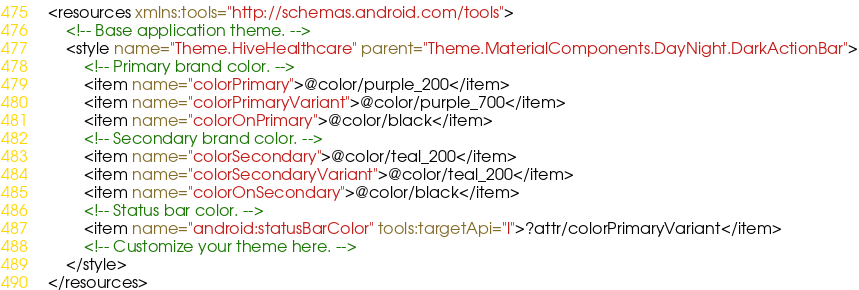<code> <loc_0><loc_0><loc_500><loc_500><_XML_><resources xmlns:tools="http://schemas.android.com/tools">
    <!-- Base application theme. -->
    <style name="Theme.HiveHealthcare" parent="Theme.MaterialComponents.DayNight.DarkActionBar">
        <!-- Primary brand color. -->
        <item name="colorPrimary">@color/purple_200</item>
        <item name="colorPrimaryVariant">@color/purple_700</item>
        <item name="colorOnPrimary">@color/black</item>
        <!-- Secondary brand color. -->
        <item name="colorSecondary">@color/teal_200</item>
        <item name="colorSecondaryVariant">@color/teal_200</item>
        <item name="colorOnSecondary">@color/black</item>
        <!-- Status bar color. -->
        <item name="android:statusBarColor" tools:targetApi="l">?attr/colorPrimaryVariant</item>
        <!-- Customize your theme here. -->
    </style>
</resources></code> 